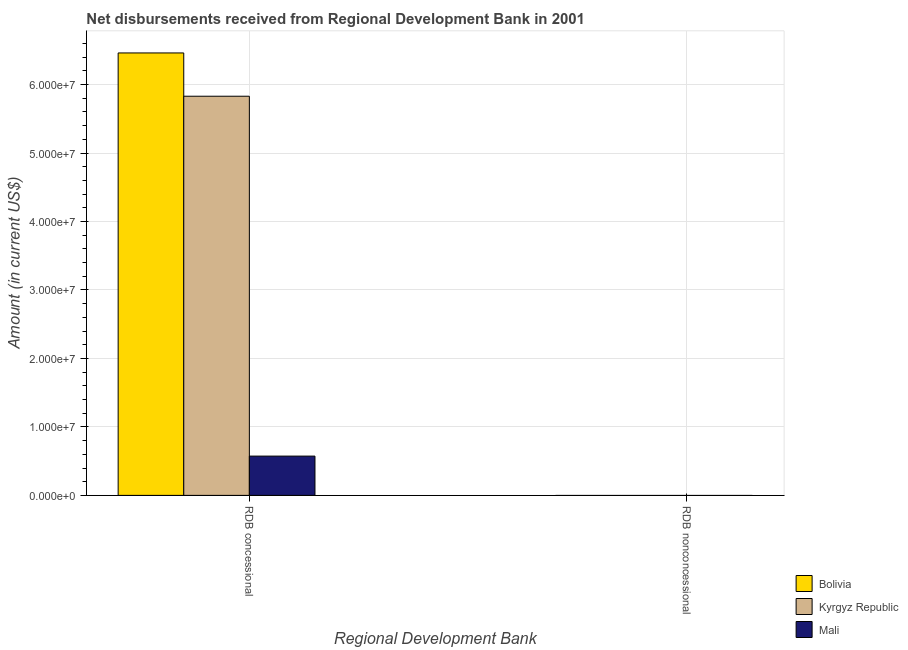How many bars are there on the 1st tick from the left?
Ensure brevity in your answer.  3. What is the label of the 1st group of bars from the left?
Your response must be concise. RDB concessional. What is the net concessional disbursements from rdb in Kyrgyz Republic?
Offer a terse response. 5.83e+07. Across all countries, what is the maximum net concessional disbursements from rdb?
Your answer should be very brief. 6.46e+07. Across all countries, what is the minimum net concessional disbursements from rdb?
Offer a terse response. 5.74e+06. What is the difference between the net concessional disbursements from rdb in Bolivia and that in Kyrgyz Republic?
Your answer should be compact. 6.32e+06. What is the difference between the net concessional disbursements from rdb in Mali and the net non concessional disbursements from rdb in Kyrgyz Republic?
Your answer should be compact. 5.74e+06. What is the average net concessional disbursements from rdb per country?
Your answer should be compact. 4.29e+07. What is the ratio of the net concessional disbursements from rdb in Mali to that in Bolivia?
Ensure brevity in your answer.  0.09. Is the net concessional disbursements from rdb in Bolivia less than that in Kyrgyz Republic?
Offer a very short reply. No. What is the difference between two consecutive major ticks on the Y-axis?
Ensure brevity in your answer.  1.00e+07. Does the graph contain any zero values?
Your answer should be very brief. Yes. Does the graph contain grids?
Your answer should be very brief. Yes. Where does the legend appear in the graph?
Your answer should be compact. Bottom right. How are the legend labels stacked?
Offer a very short reply. Vertical. What is the title of the graph?
Ensure brevity in your answer.  Net disbursements received from Regional Development Bank in 2001. What is the label or title of the X-axis?
Your response must be concise. Regional Development Bank. What is the Amount (in current US$) in Bolivia in RDB concessional?
Your answer should be compact. 6.46e+07. What is the Amount (in current US$) in Kyrgyz Republic in RDB concessional?
Keep it short and to the point. 5.83e+07. What is the Amount (in current US$) of Mali in RDB concessional?
Your answer should be compact. 5.74e+06. Across all Regional Development Bank, what is the maximum Amount (in current US$) in Bolivia?
Give a very brief answer. 6.46e+07. Across all Regional Development Bank, what is the maximum Amount (in current US$) in Kyrgyz Republic?
Offer a very short reply. 5.83e+07. Across all Regional Development Bank, what is the maximum Amount (in current US$) in Mali?
Your answer should be compact. 5.74e+06. Across all Regional Development Bank, what is the minimum Amount (in current US$) in Bolivia?
Provide a succinct answer. 0. Across all Regional Development Bank, what is the minimum Amount (in current US$) in Kyrgyz Republic?
Your answer should be compact. 0. What is the total Amount (in current US$) in Bolivia in the graph?
Give a very brief answer. 6.46e+07. What is the total Amount (in current US$) in Kyrgyz Republic in the graph?
Give a very brief answer. 5.83e+07. What is the total Amount (in current US$) in Mali in the graph?
Offer a very short reply. 5.74e+06. What is the average Amount (in current US$) in Bolivia per Regional Development Bank?
Give a very brief answer. 3.23e+07. What is the average Amount (in current US$) of Kyrgyz Republic per Regional Development Bank?
Make the answer very short. 2.92e+07. What is the average Amount (in current US$) in Mali per Regional Development Bank?
Offer a very short reply. 2.87e+06. What is the difference between the Amount (in current US$) in Bolivia and Amount (in current US$) in Kyrgyz Republic in RDB concessional?
Provide a succinct answer. 6.32e+06. What is the difference between the Amount (in current US$) in Bolivia and Amount (in current US$) in Mali in RDB concessional?
Provide a short and direct response. 5.89e+07. What is the difference between the Amount (in current US$) in Kyrgyz Republic and Amount (in current US$) in Mali in RDB concessional?
Provide a short and direct response. 5.26e+07. What is the difference between the highest and the lowest Amount (in current US$) in Bolivia?
Keep it short and to the point. 6.46e+07. What is the difference between the highest and the lowest Amount (in current US$) in Kyrgyz Republic?
Give a very brief answer. 5.83e+07. What is the difference between the highest and the lowest Amount (in current US$) in Mali?
Your answer should be compact. 5.74e+06. 